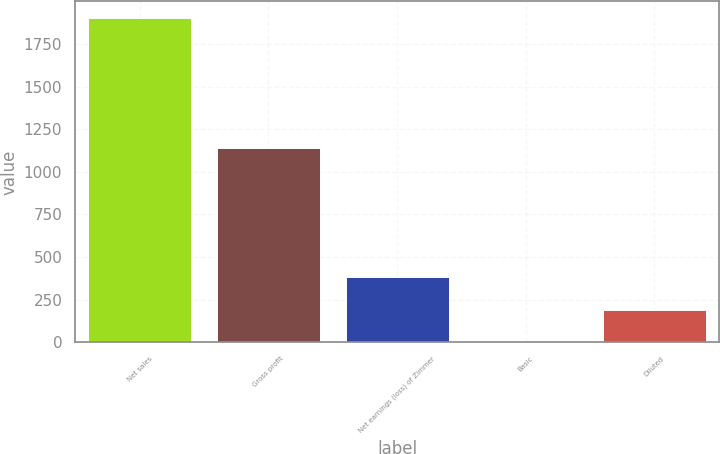Convert chart to OTSL. <chart><loc_0><loc_0><loc_500><loc_500><bar_chart><fcel>Net sales<fcel>Gross profit<fcel>Net earnings (loss) of Zimmer<fcel>Basic<fcel>Diluted<nl><fcel>1904<fcel>1136.8<fcel>381.24<fcel>0.54<fcel>190.89<nl></chart> 